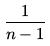Convert formula to latex. <formula><loc_0><loc_0><loc_500><loc_500>\frac { 1 } { n - 1 }</formula> 